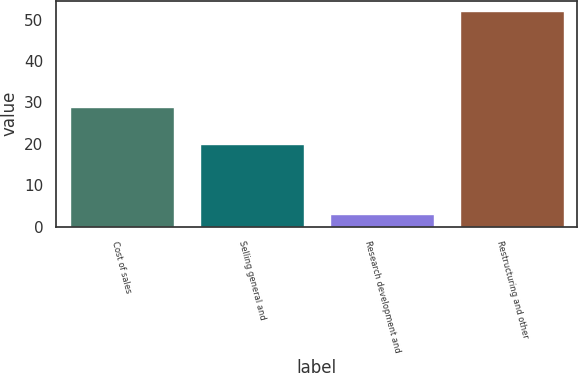Convert chart to OTSL. <chart><loc_0><loc_0><loc_500><loc_500><bar_chart><fcel>Cost of sales<fcel>Selling general and<fcel>Research development and<fcel>Restructuring and other<nl><fcel>29<fcel>20<fcel>3<fcel>52<nl></chart> 